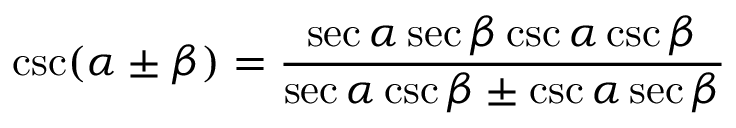<formula> <loc_0><loc_0><loc_500><loc_500>\csc ( \alpha \pm \beta ) = { \frac { \sec \alpha \sec \beta \csc \alpha \csc \beta } { \sec \alpha \csc \beta \pm \csc \alpha \sec \beta } }</formula> 